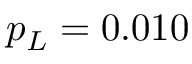<formula> <loc_0><loc_0><loc_500><loc_500>p _ { L } = 0 . 0 1 0</formula> 